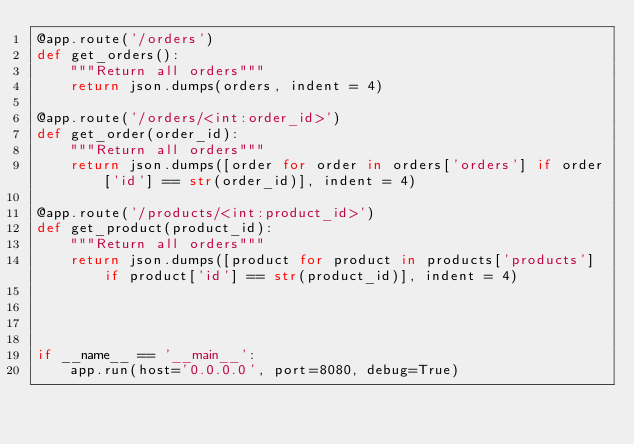<code> <loc_0><loc_0><loc_500><loc_500><_Python_>@app.route('/orders')
def get_orders():
    """Return all orders"""
    return json.dumps(orders, indent = 4)   

@app.route('/orders/<int:order_id>')
def get_order(order_id):
    """Return all orders"""
    return json.dumps([order for order in orders['orders'] if order['id'] == str(order_id)], indent = 4)   

@app.route('/products/<int:product_id>')
def get_product(product_id):
    """Return all orders"""
    return json.dumps([product for product in products['products'] if product['id'] == str(product_id)], indent = 4)   


    

if __name__ == '__main__':
    app.run(host='0.0.0.0', port=8080, debug=True)</code> 